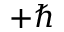Convert formula to latex. <formula><loc_0><loc_0><loc_500><loc_500>+ \hbar</formula> 